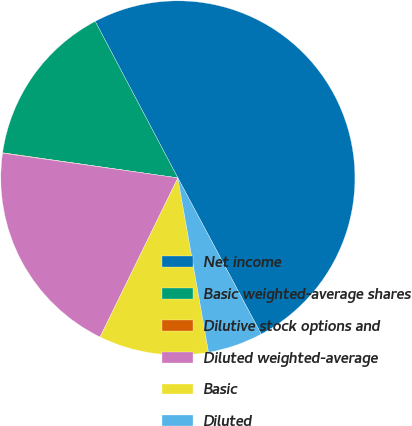Convert chart. <chart><loc_0><loc_0><loc_500><loc_500><pie_chart><fcel>Net income<fcel>Basic weighted-average shares<fcel>Dilutive stock options and<fcel>Diluted weighted-average<fcel>Basic<fcel>Diluted<nl><fcel>49.93%<fcel>15.0%<fcel>0.04%<fcel>19.99%<fcel>10.01%<fcel>5.03%<nl></chart> 